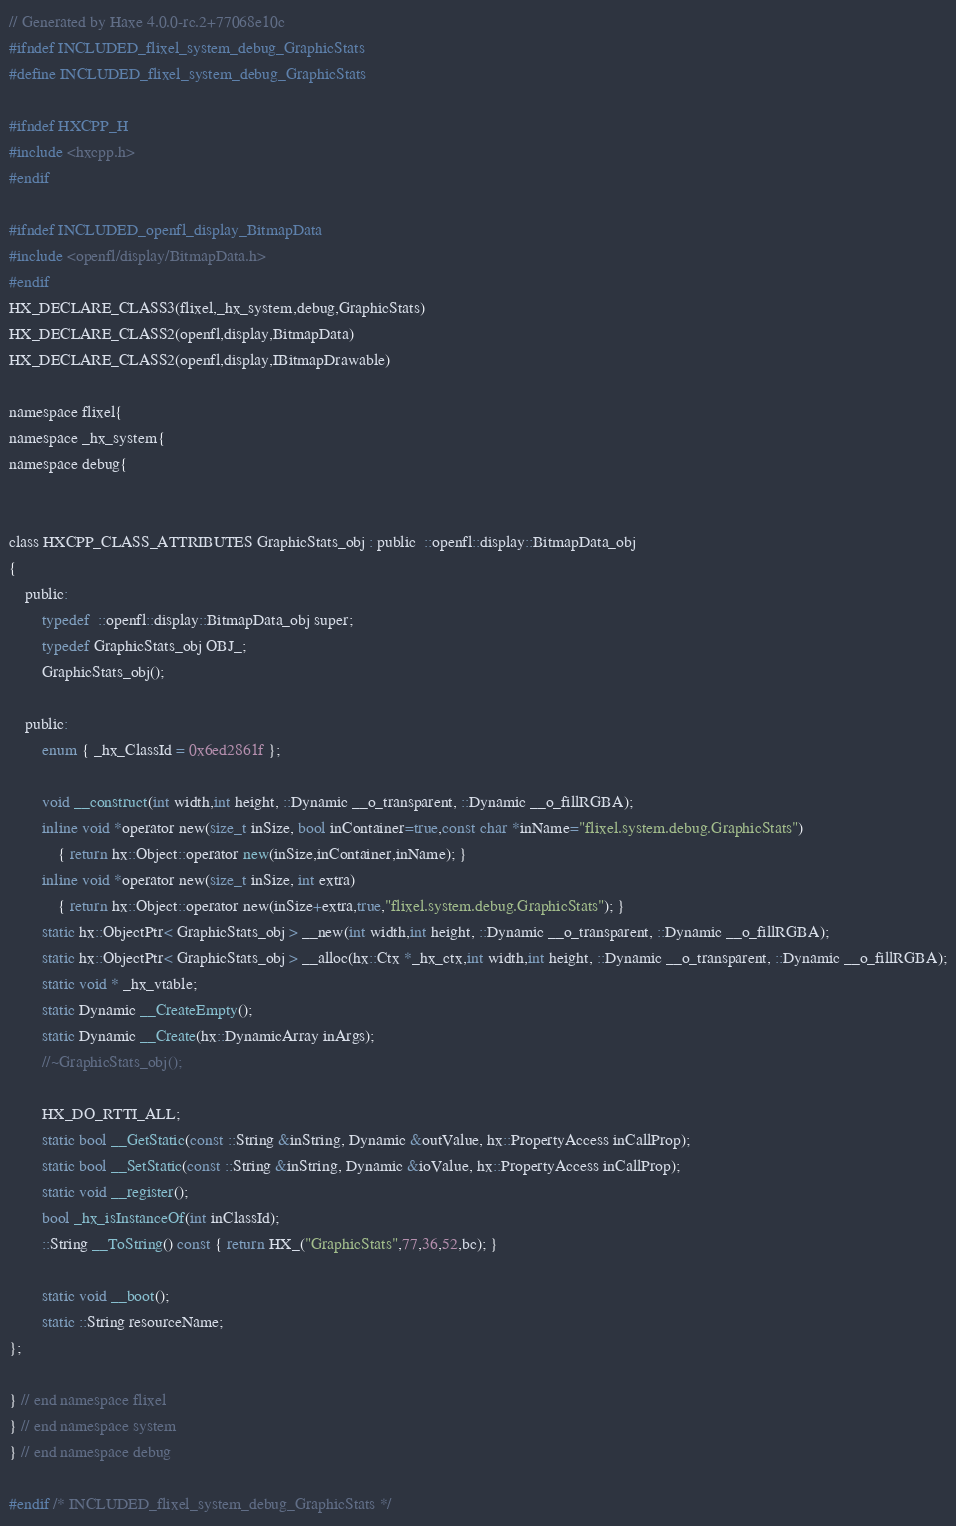Convert code to text. <code><loc_0><loc_0><loc_500><loc_500><_C_>// Generated by Haxe 4.0.0-rc.2+77068e10c
#ifndef INCLUDED_flixel_system_debug_GraphicStats
#define INCLUDED_flixel_system_debug_GraphicStats

#ifndef HXCPP_H
#include <hxcpp.h>
#endif

#ifndef INCLUDED_openfl_display_BitmapData
#include <openfl/display/BitmapData.h>
#endif
HX_DECLARE_CLASS3(flixel,_hx_system,debug,GraphicStats)
HX_DECLARE_CLASS2(openfl,display,BitmapData)
HX_DECLARE_CLASS2(openfl,display,IBitmapDrawable)

namespace flixel{
namespace _hx_system{
namespace debug{


class HXCPP_CLASS_ATTRIBUTES GraphicStats_obj : public  ::openfl::display::BitmapData_obj
{
	public:
		typedef  ::openfl::display::BitmapData_obj super;
		typedef GraphicStats_obj OBJ_;
		GraphicStats_obj();

	public:
		enum { _hx_ClassId = 0x6ed2861f };

		void __construct(int width,int height, ::Dynamic __o_transparent, ::Dynamic __o_fillRGBA);
		inline void *operator new(size_t inSize, bool inContainer=true,const char *inName="flixel.system.debug.GraphicStats")
			{ return hx::Object::operator new(inSize,inContainer,inName); }
		inline void *operator new(size_t inSize, int extra)
			{ return hx::Object::operator new(inSize+extra,true,"flixel.system.debug.GraphicStats"); }
		static hx::ObjectPtr< GraphicStats_obj > __new(int width,int height, ::Dynamic __o_transparent, ::Dynamic __o_fillRGBA);
		static hx::ObjectPtr< GraphicStats_obj > __alloc(hx::Ctx *_hx_ctx,int width,int height, ::Dynamic __o_transparent, ::Dynamic __o_fillRGBA);
		static void * _hx_vtable;
		static Dynamic __CreateEmpty();
		static Dynamic __Create(hx::DynamicArray inArgs);
		//~GraphicStats_obj();

		HX_DO_RTTI_ALL;
		static bool __GetStatic(const ::String &inString, Dynamic &outValue, hx::PropertyAccess inCallProp);
		static bool __SetStatic(const ::String &inString, Dynamic &ioValue, hx::PropertyAccess inCallProp);
		static void __register();
		bool _hx_isInstanceOf(int inClassId);
		::String __ToString() const { return HX_("GraphicStats",77,36,52,bc); }

		static void __boot();
		static ::String resourceName;
};

} // end namespace flixel
} // end namespace system
} // end namespace debug

#endif /* INCLUDED_flixel_system_debug_GraphicStats */ 
</code> 